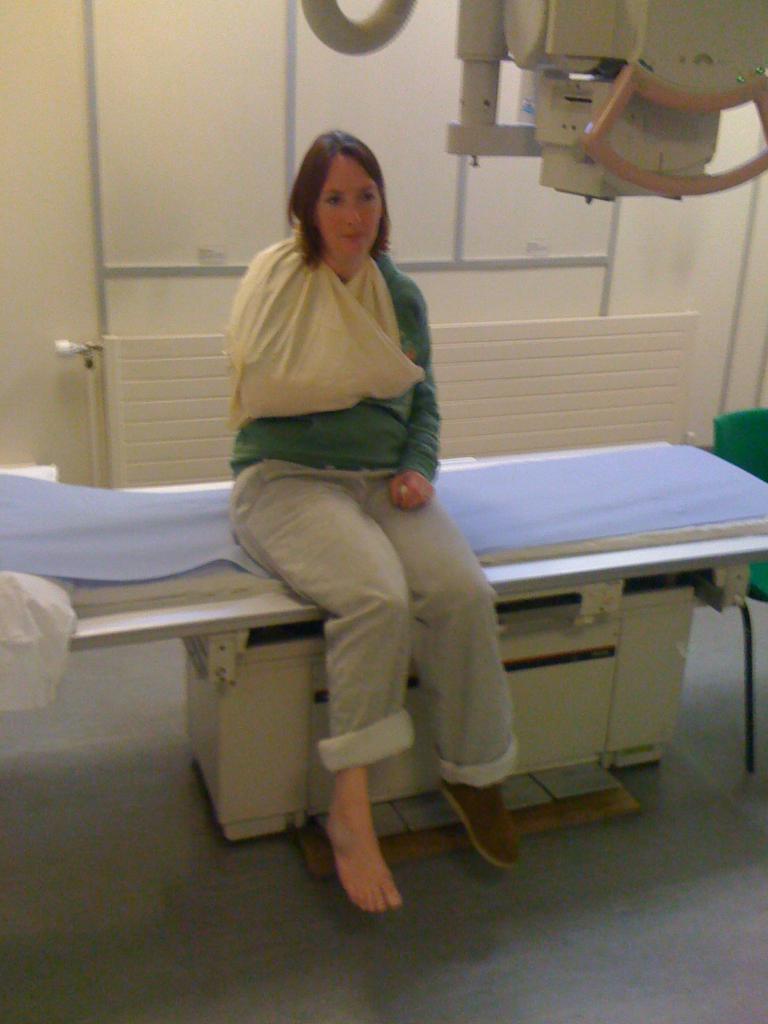Describe this image in one or two sentences. In the foreground I can see a woman is sitting on a bed. In the background I can see a wall, bench, chair and a machine. This image is taken may be in a room. 